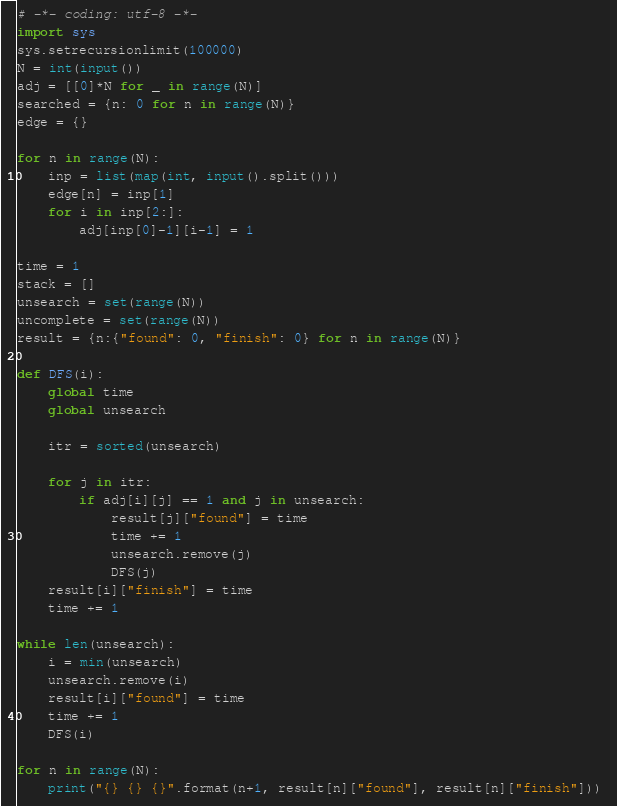Convert code to text. <code><loc_0><loc_0><loc_500><loc_500><_Python_># -*- coding: utf-8 -*-
import sys
sys.setrecursionlimit(100000)
N = int(input())
adj = [[0]*N for _ in range(N)]
searched = {n: 0 for n in range(N)}
edge = {}

for n in range(N):
    inp = list(map(int, input().split()))
    edge[n] = inp[1]
    for i in inp[2:]:
        adj[inp[0]-1][i-1] = 1

time = 1
stack = []
unsearch = set(range(N))
uncomplete = set(range(N))
result = {n:{"found": 0, "finish": 0} for n in range(N)}

def DFS(i):
    global time
    global unsearch
    
    itr = sorted(unsearch)
    
    for j in itr:
        if adj[i][j] == 1 and j in unsearch:
            result[j]["found"] = time
            time += 1
            unsearch.remove(j)
            DFS(j)
    result[i]["finish"] = time
    time += 1
    
while len(unsearch):
    i = min(unsearch)
    unsearch.remove(i)
    result[i]["found"] = time
    time += 1
    DFS(i)

for n in range(N):
    print("{} {} {}".format(n+1, result[n]["found"], result[n]["finish"])) </code> 